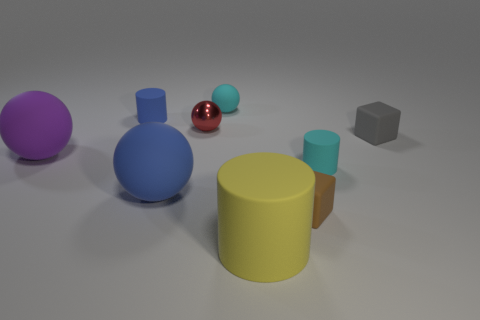There is a blue matte object that is the same size as the purple matte sphere; what is its shape?
Your answer should be compact. Sphere. There is a rubber cylinder behind the red ball; what color is it?
Your answer should be very brief. Blue. How many objects are cubes that are in front of the purple thing or balls left of the tiny cyan sphere?
Provide a succinct answer. 4. Do the brown block and the red metallic object have the same size?
Ensure brevity in your answer.  Yes. How many balls are cyan rubber objects or tiny gray rubber objects?
Make the answer very short. 1. How many small matte cylinders are left of the big blue ball and in front of the small blue rubber cylinder?
Your answer should be very brief. 0. Do the brown block and the rubber cylinder behind the tiny gray cube have the same size?
Your response must be concise. Yes. Are there any yellow cylinders on the left side of the yellow cylinder on the right side of the blue rubber object that is behind the red sphere?
Offer a terse response. No. What is the material of the cylinder in front of the matte ball that is in front of the tiny cyan rubber cylinder?
Make the answer very short. Rubber. What is the thing that is both right of the yellow cylinder and behind the cyan cylinder made of?
Make the answer very short. Rubber. 